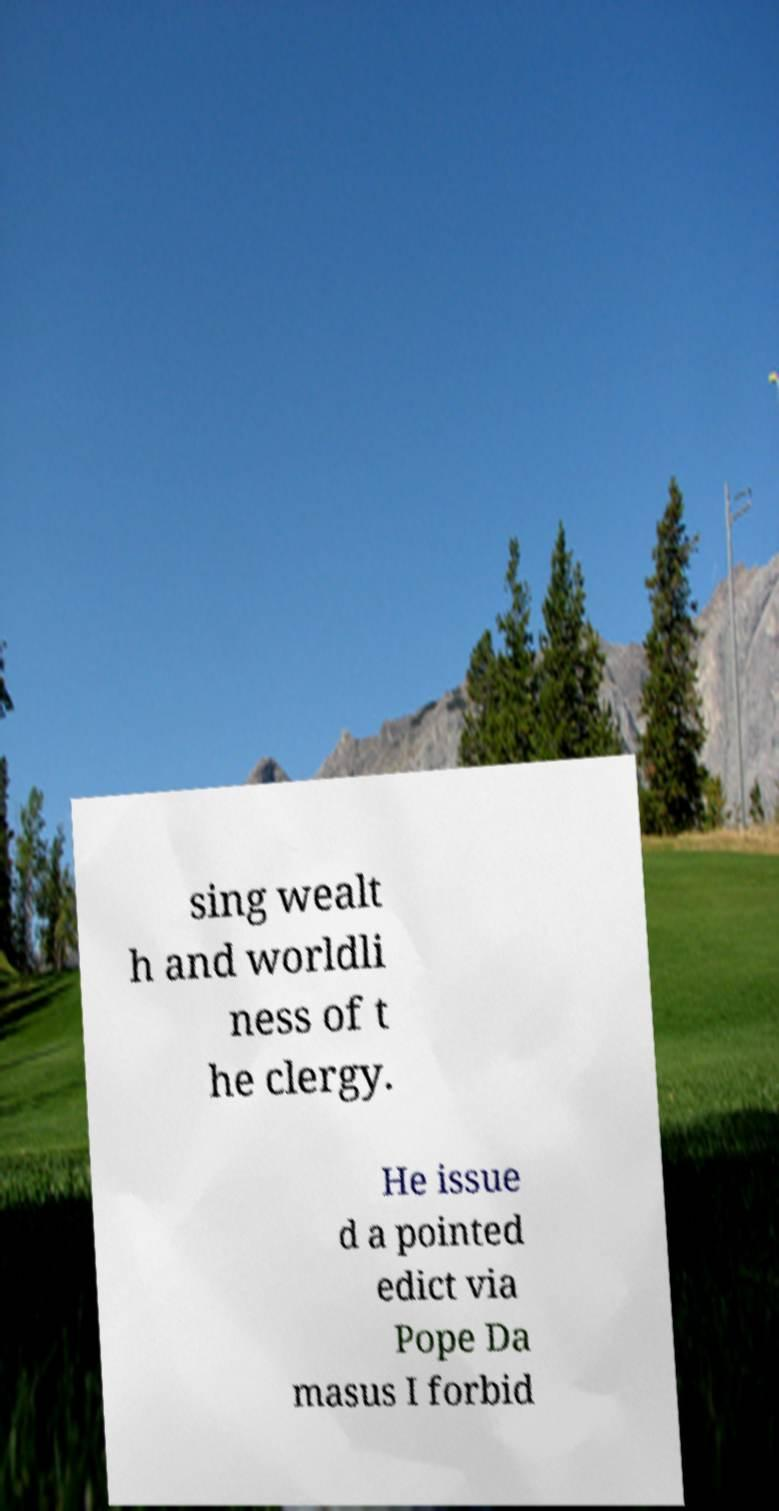Can you accurately transcribe the text from the provided image for me? sing wealt h and worldli ness of t he clergy. He issue d a pointed edict via Pope Da masus I forbid 